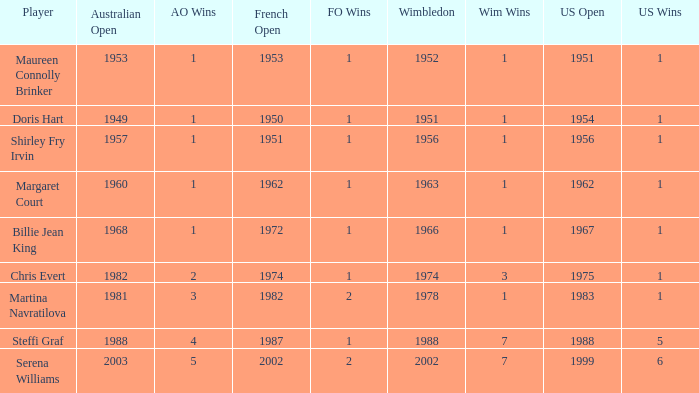What year did Martina Navratilova win Wimbledon? 1978.0. 